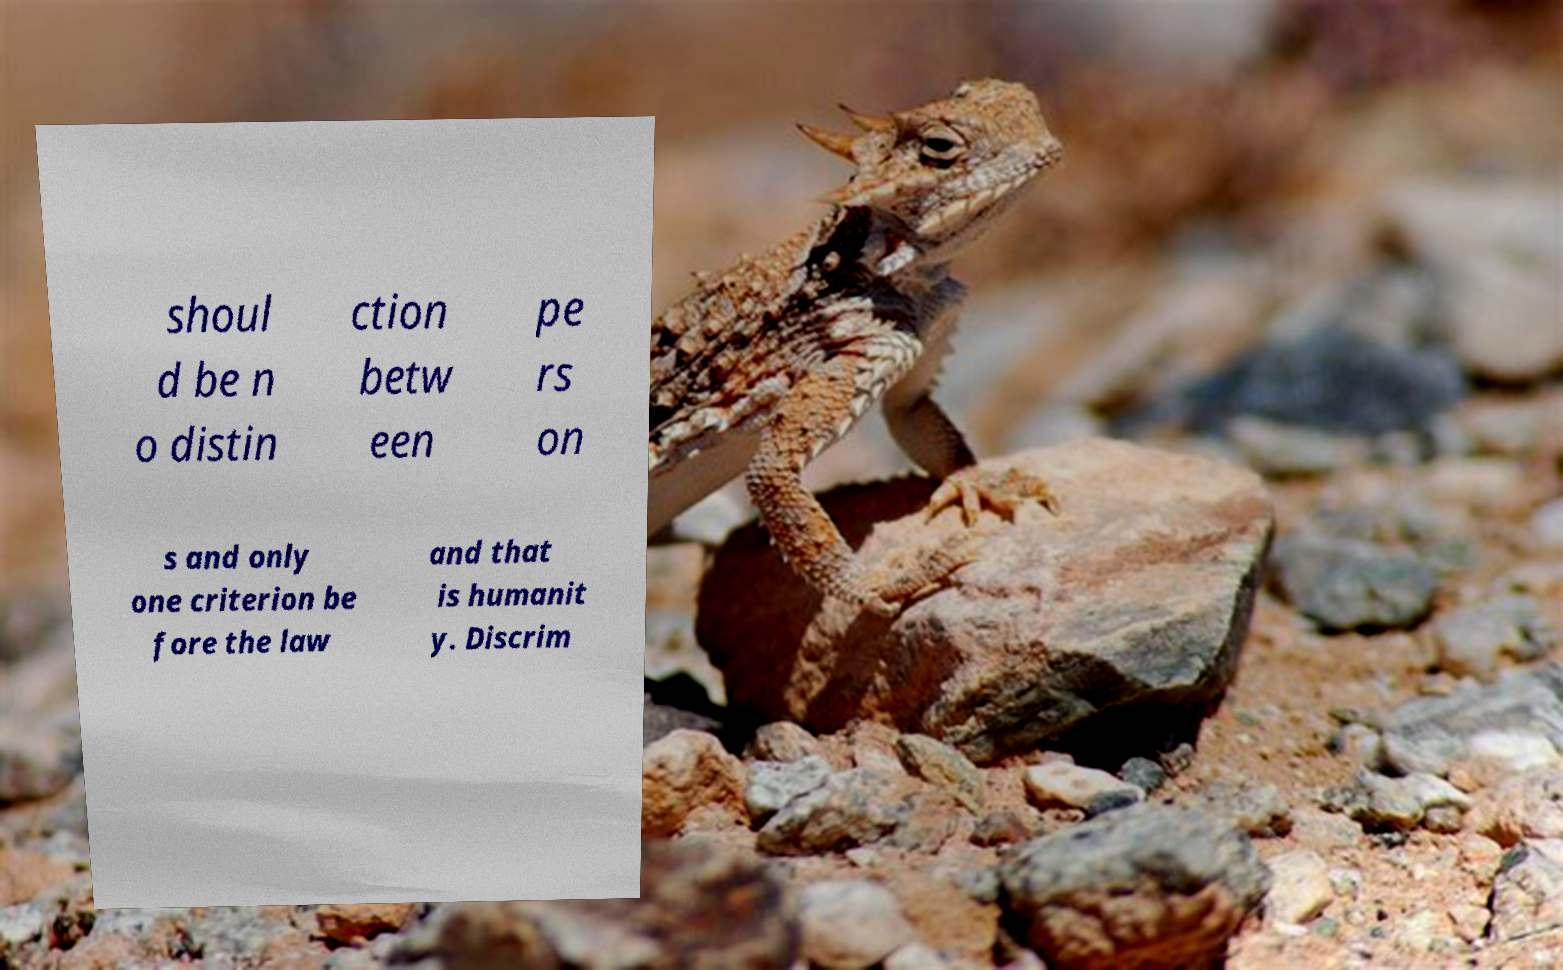Please identify and transcribe the text found in this image. shoul d be n o distin ction betw een pe rs on s and only one criterion be fore the law and that is humanit y. Discrim 